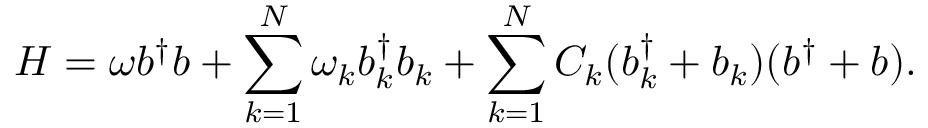Convert formula to latex. <formula><loc_0><loc_0><loc_500><loc_500>H = \omega b ^ { \dagger } b + \sum _ { k = 1 } ^ { N } \omega _ { k } b _ { k } ^ { \dagger } b _ { k } + \sum _ { k = 1 } ^ { N } C _ { k } ( b _ { k } ^ { \dagger } + b _ { k } ) ( b ^ { \dagger } + b ) .</formula> 